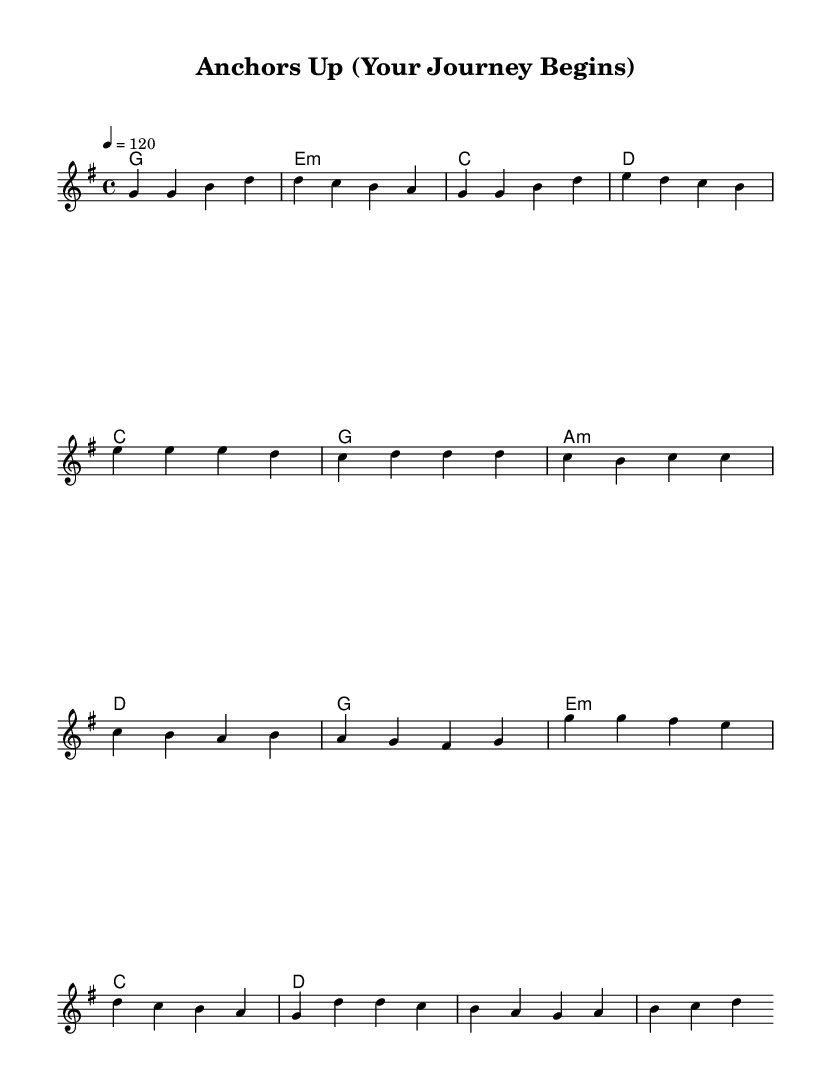What is the key signature of this music? The key signature is G major, which has one sharp (F#).
Answer: G major What is the time signature of this music? The time signature is 4/4, indicating four beats per measure.
Answer: 4/4 What is the tempo marking for this music? The tempo marking is quarter note = 120 beats per minute.
Answer: 120 How many sections are in the piece? The piece contains three distinct sections: verse, pre-chorus, and chorus.
Answer: Three Which chord follows the first melody note in the verse? The first melody note in the verse is G, and it is accompanied by a G major chord.
Answer: G major What is the highest note in the melody? The highest note in the melody is D, found in the chorus section.
Answer: D Which section of the piece features the most chords? The pre-chorus features four chords, which is more than the other sections.
Answer: Pre-chorus 